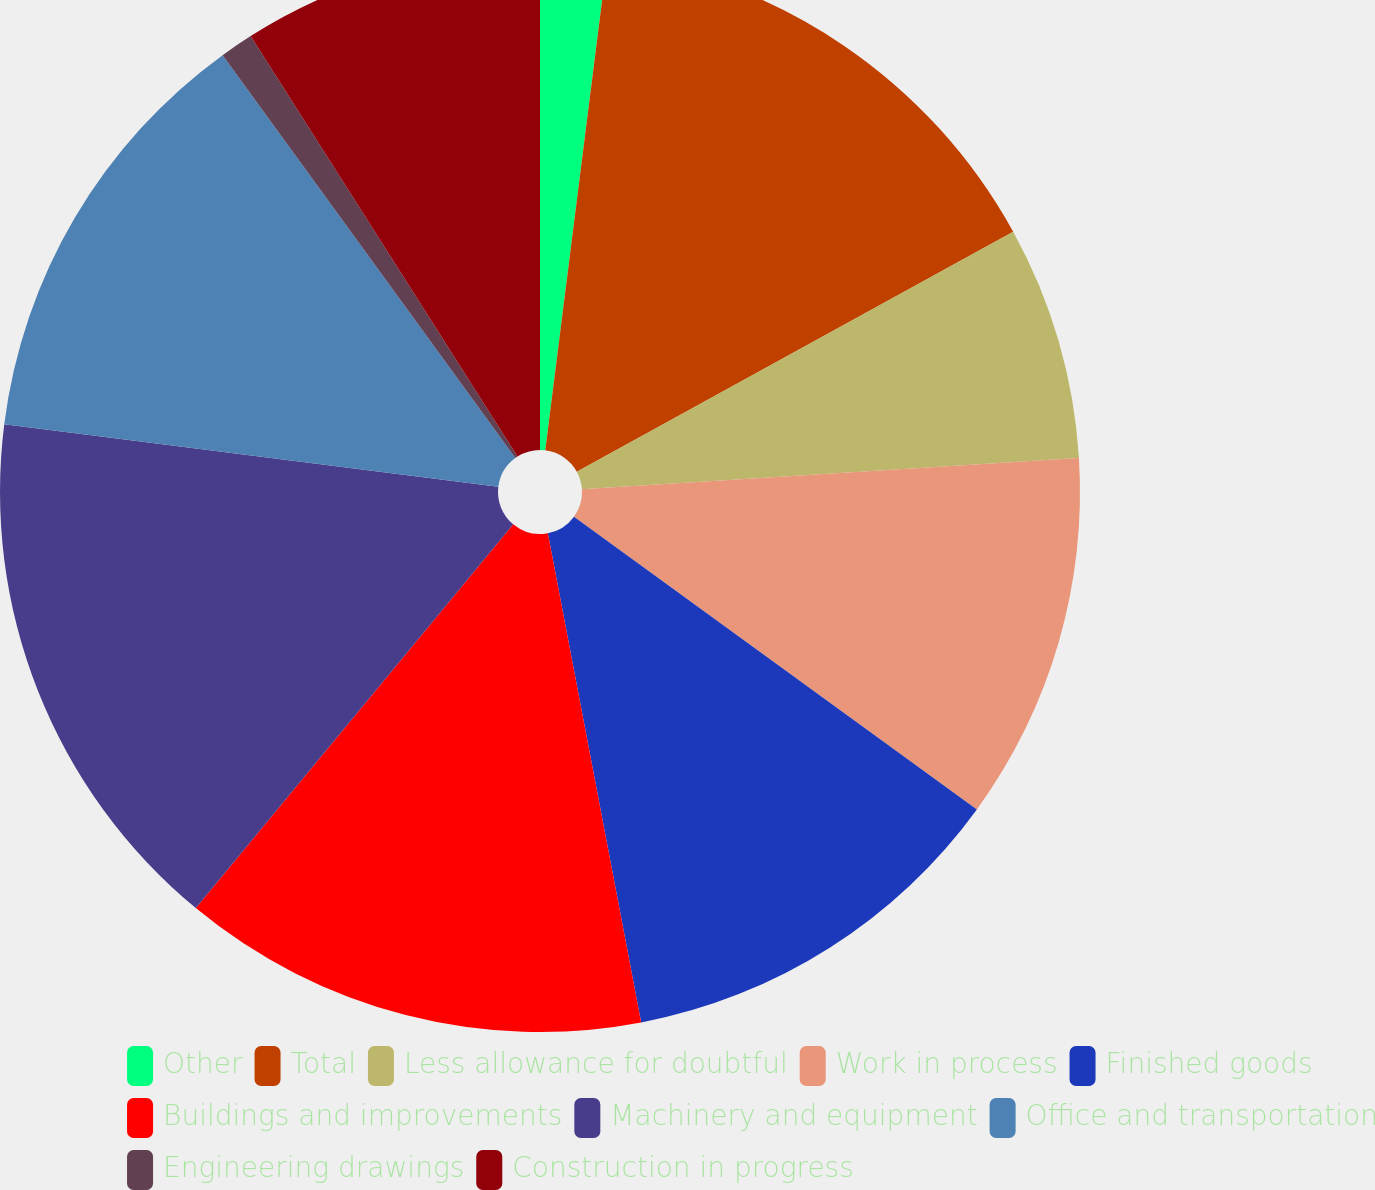Convert chart. <chart><loc_0><loc_0><loc_500><loc_500><pie_chart><fcel>Other<fcel>Total<fcel>Less allowance for doubtful<fcel>Work in process<fcel>Finished goods<fcel>Buildings and improvements<fcel>Machinery and equipment<fcel>Office and transportation<fcel>Engineering drawings<fcel>Construction in progress<nl><fcel>2.0%<fcel>15.0%<fcel>7.0%<fcel>11.0%<fcel>12.0%<fcel>14.0%<fcel>16.0%<fcel>13.0%<fcel>1.0%<fcel>9.0%<nl></chart> 